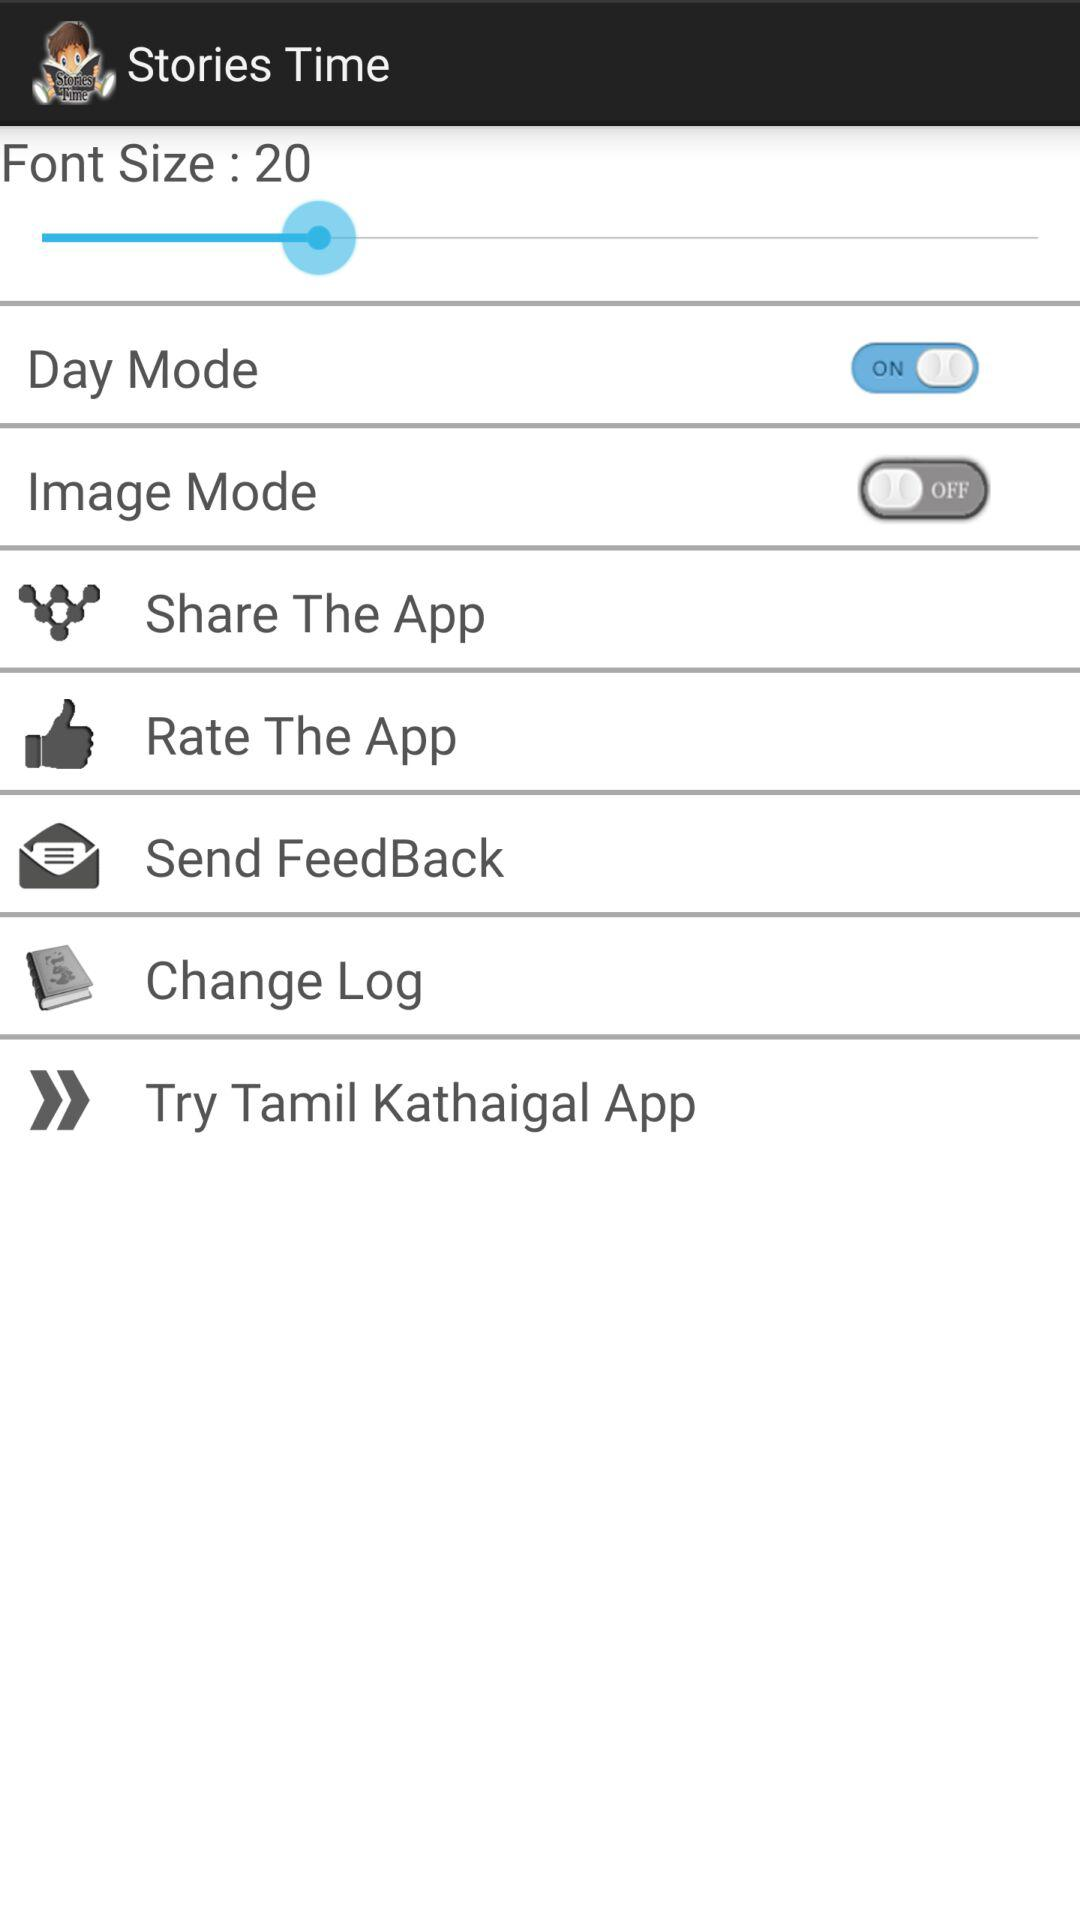What is the status of "Day Mode"? The status is "on". 